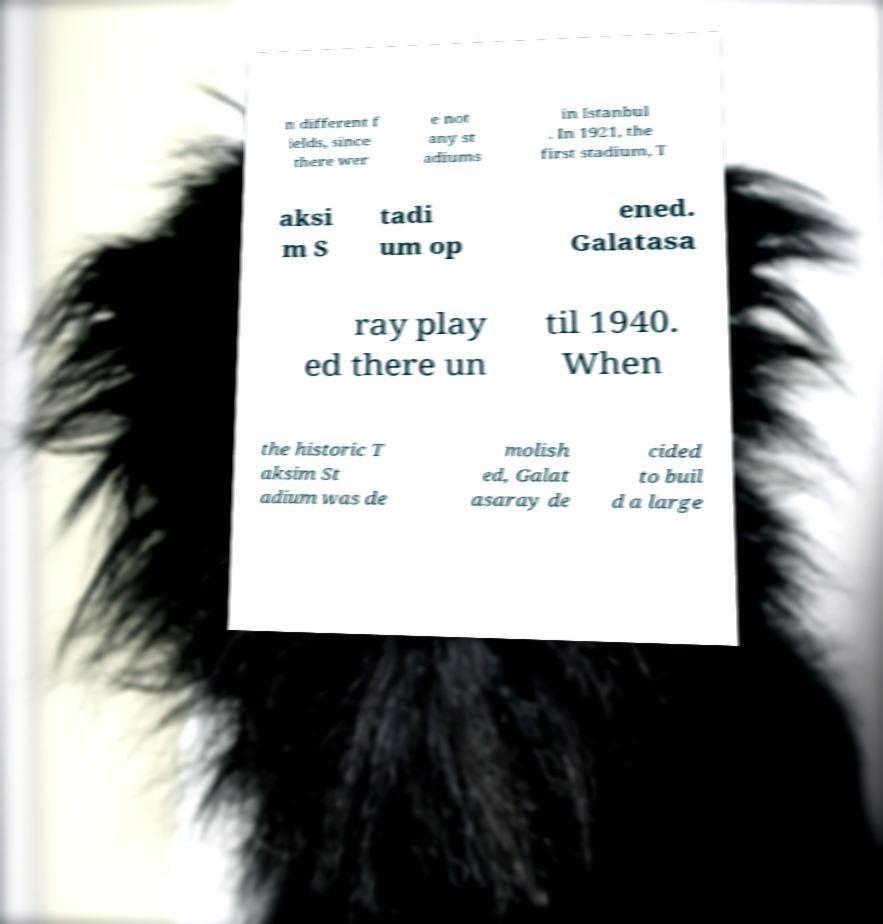There's text embedded in this image that I need extracted. Can you transcribe it verbatim? n different f ields, since there wer e not any st adiums in Istanbul . In 1921, the first stadium, T aksi m S tadi um op ened. Galatasa ray play ed there un til 1940. When the historic T aksim St adium was de molish ed, Galat asaray de cided to buil d a large 